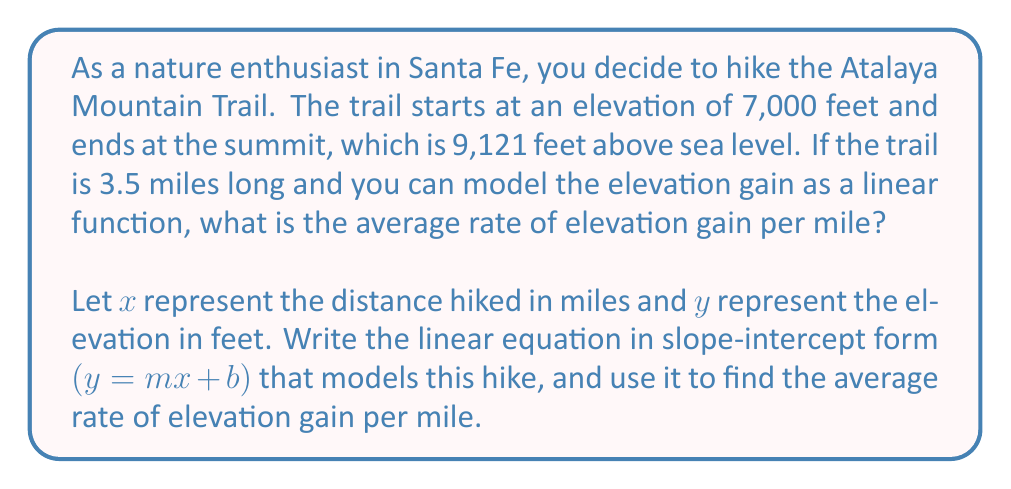Show me your answer to this math problem. To solve this problem, we'll follow these steps:

1. Identify the given information:
   - Starting elevation: 7,000 feet (y-intercept, b)
   - Ending elevation: 9,121 feet
   - Trail length: 3.5 miles

2. Calculate the total elevation gain:
   $9,121 - 7,000 = 2,121$ feet

3. Find the slope (m) of the linear equation, which represents the average rate of elevation gain per mile:
   $$m = \frac{\text{change in elevation}}{\text{change in distance}} = \frac{2,121 \text{ feet}}{3.5 \text{ miles}} = 606 \text{ feet/mile}$$

4. Write the linear equation in slope-intercept form:
   $$y = 606x + 7000$$

   Where:
   - $y$ is the elevation in feet
   - $x$ is the distance hiked in miles
   - 606 is the slope (average rate of elevation gain per mile)
   - 7000 is the y-intercept (starting elevation)

5. Verify the equation:
   At the end of the trail $(x = 3.5)$, the elevation should be 9,121 feet:
   $$y = 606(3.5) + 7000 = 2,121 + 7,000 = 9,121 \text{ feet}$$

Therefore, the average rate of elevation gain per mile is 606 feet/mile.
Answer: The average rate of elevation gain is 606 feet per mile. The linear equation modeling the hike is $y = 606x + 7000$. 